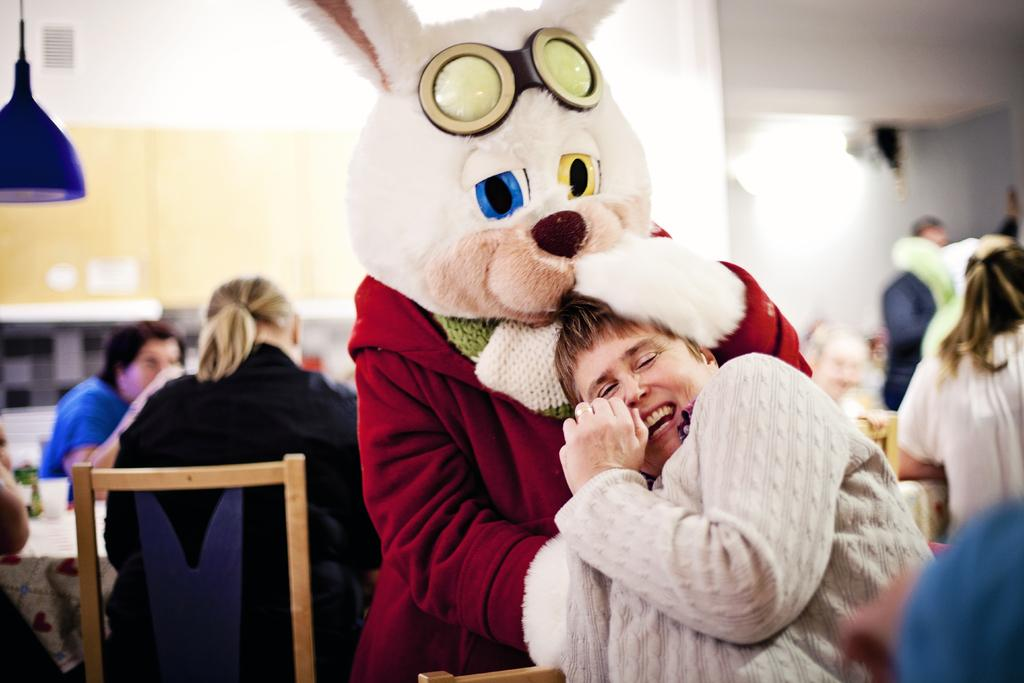What object can be seen in the picture besides the person? There is a teddy in the picture. What is the person doing in the picture? The person is sitting on a chair. What is in front of the person? There is a table in front of the person. What is on top of the table? There is a light on top of the table. What type of dress is the person wearing in the picture? The provided facts do not mention any dress or apparel worn by the person in the image. How does the person stretch in the picture? The provided facts do not mention any stretching or movement by the person in the image. 